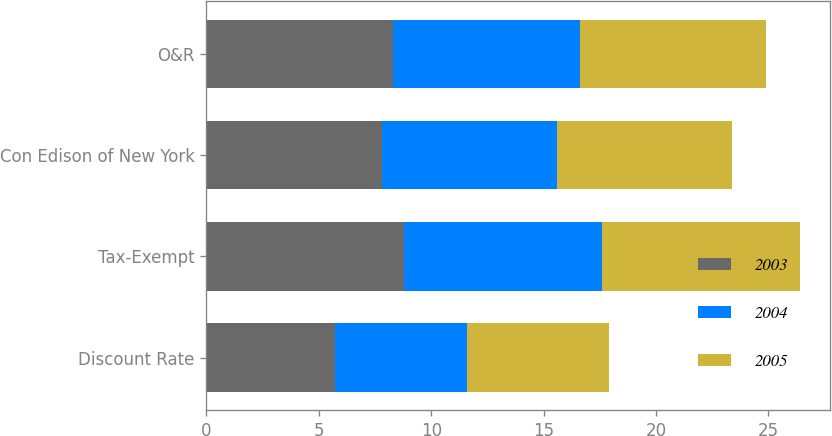<chart> <loc_0><loc_0><loc_500><loc_500><stacked_bar_chart><ecel><fcel>Discount Rate<fcel>Tax-Exempt<fcel>Con Edison of New York<fcel>O&R<nl><fcel>2003<fcel>5.7<fcel>8.8<fcel>7.8<fcel>8.3<nl><fcel>2004<fcel>5.9<fcel>8.8<fcel>7.8<fcel>8.3<nl><fcel>2005<fcel>6.3<fcel>8.8<fcel>7.8<fcel>8.3<nl></chart> 